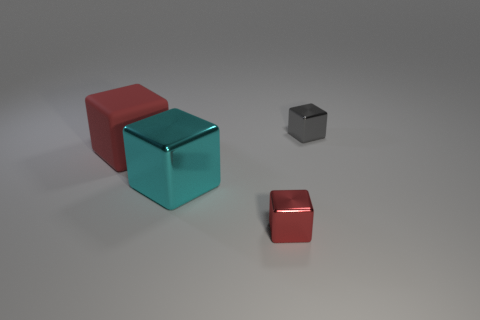What material do the objects in the image seem to be made of? The objects in the image appear to be made of different materials. The cube in the front with a reflective surface might be metallic, resembling polished stainless steel, while the other colored cubes appear to have a matte finish, perhaps suggesting a plastic or painted wood material. 